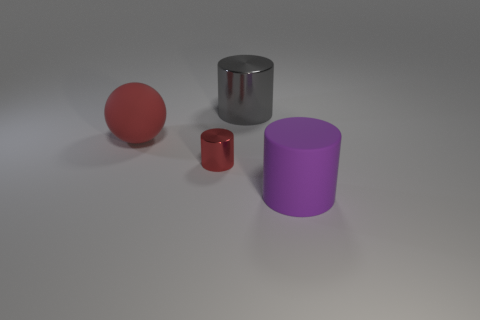Add 4 brown cylinders. How many objects exist? 8 Subtract all big cylinders. How many cylinders are left? 1 Subtract all purple cylinders. How many cylinders are left? 2 Subtract all cylinders. How many objects are left? 1 Subtract 1 spheres. How many spheres are left? 0 Subtract all gray cylinders. Subtract all brown balls. How many cylinders are left? 2 Subtract all brown spheres. How many blue cylinders are left? 0 Subtract all red spheres. Subtract all small purple cylinders. How many objects are left? 3 Add 1 big red matte objects. How many big red matte objects are left? 2 Add 1 large red metal blocks. How many large red metal blocks exist? 1 